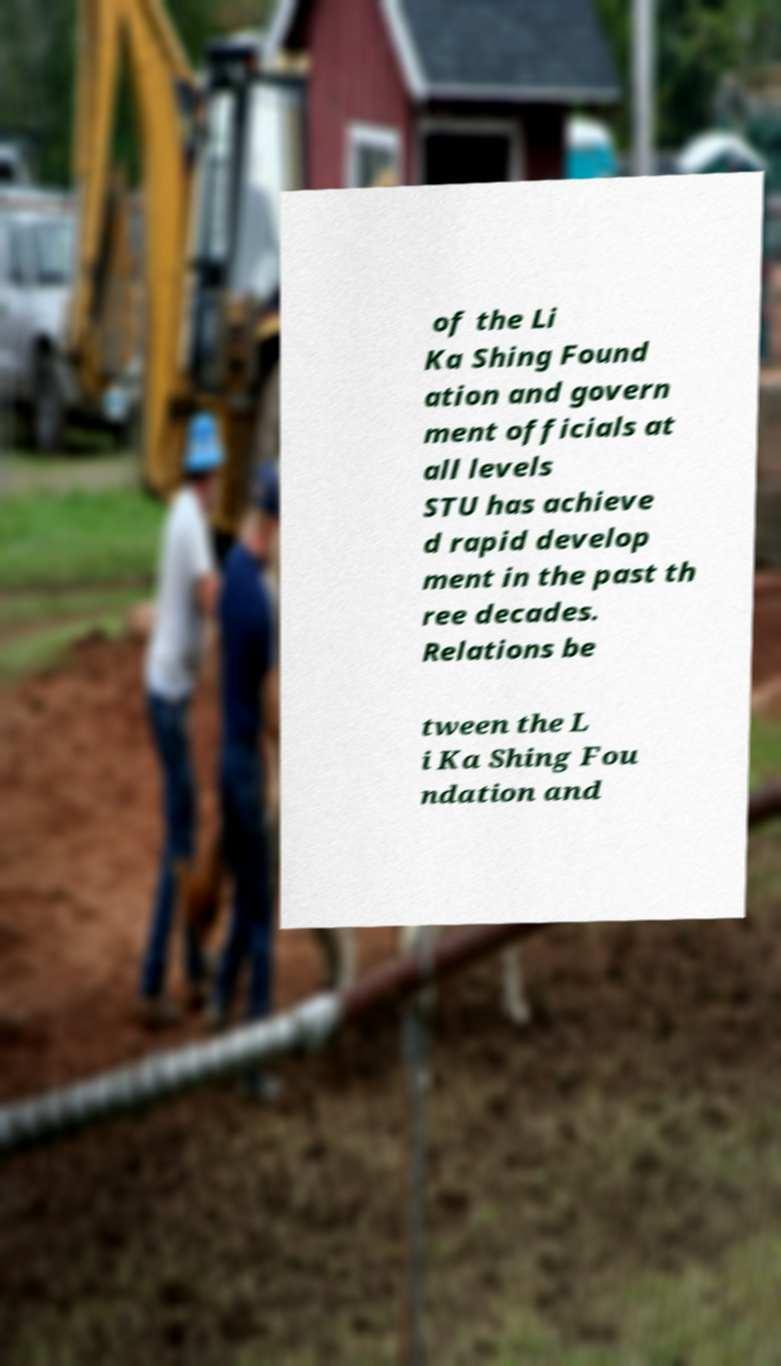I need the written content from this picture converted into text. Can you do that? of the Li Ka Shing Found ation and govern ment officials at all levels STU has achieve d rapid develop ment in the past th ree decades. Relations be tween the L i Ka Shing Fou ndation and 